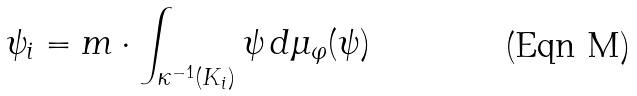Convert formula to latex. <formula><loc_0><loc_0><loc_500><loc_500>\psi _ { i } = m \cdot \int _ { \kappa ^ { - 1 } ( K _ { i } ) } \psi \, d \mu _ { \varphi } ( \psi )</formula> 